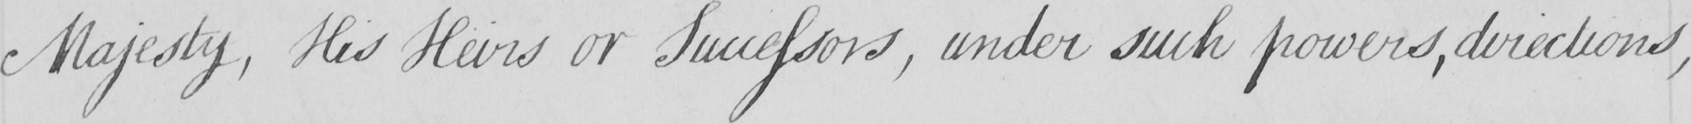Please transcribe the handwritten text in this image. Majesty , His Heirs or Successors , under such powers , directions , 